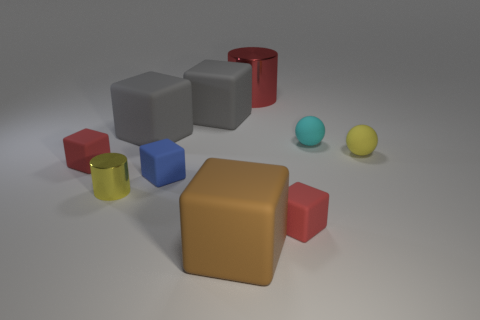Subtract all blue spheres. How many gray blocks are left? 2 Subtract all large brown blocks. How many blocks are left? 5 Subtract 1 cubes. How many cubes are left? 5 Subtract all red blocks. How many blocks are left? 4 Subtract all green cubes. Subtract all yellow cylinders. How many cubes are left? 6 Subtract all cylinders. How many objects are left? 8 Subtract 0 gray cylinders. How many objects are left? 10 Subtract all red cubes. Subtract all cylinders. How many objects are left? 6 Add 7 big brown matte blocks. How many big brown matte blocks are left? 8 Add 10 tiny green rubber cylinders. How many tiny green rubber cylinders exist? 10 